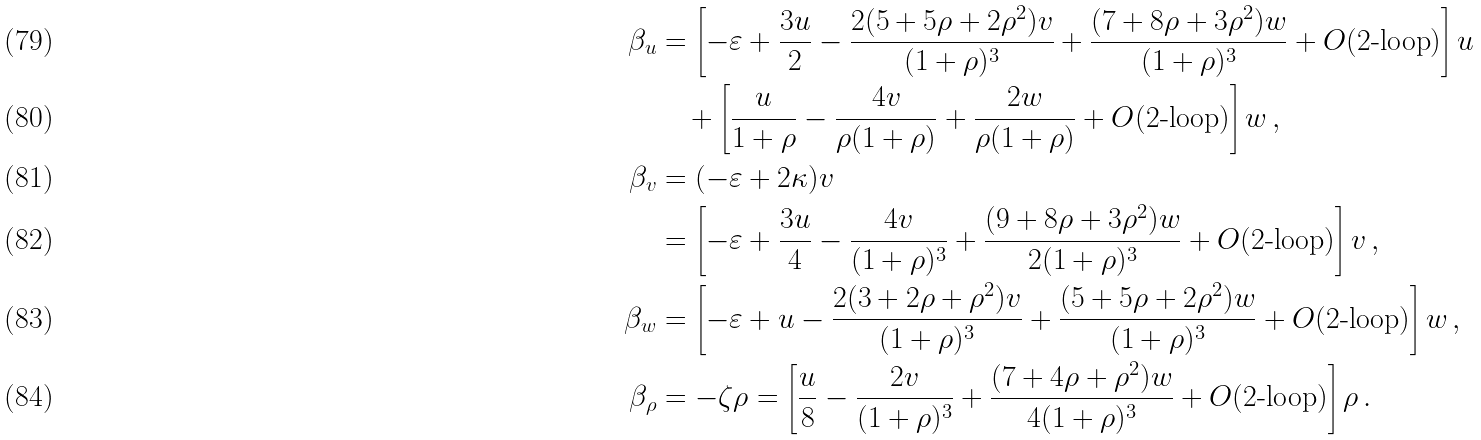<formula> <loc_0><loc_0><loc_500><loc_500>\beta _ { u } & = \left [ - \varepsilon + \frac { 3 u } { 2 } - \frac { 2 ( 5 + 5 \rho + 2 \rho ^ { 2 } ) v } { ( 1 + \rho ) ^ { 3 } } + \frac { ( 7 + 8 \rho + 3 \rho ^ { 2 } ) w } { ( 1 + \rho ) ^ { 3 } } + O ( \text {2-loop} ) \right ] u \\ & \quad + \left [ \frac { u } { 1 + \rho } - \frac { 4 v } { \rho ( 1 + \rho ) } + \frac { 2 w } { \rho ( 1 + \rho ) } + O ( \text {2-loop} ) \right ] w \, , \\ \beta _ { v } & = ( - \varepsilon + 2 \kappa ) v \\ & = \left [ - \varepsilon + \frac { 3 u } { 4 } - \frac { 4 v } { ( 1 + \rho ) ^ { 3 } } + \frac { ( 9 + 8 \rho + 3 \rho ^ { 2 } ) w } { 2 ( 1 + \rho ) ^ { 3 } } + O ( \text {2-loop} ) \right ] v \, , \\ \beta _ { w } & = \left [ - \varepsilon + u - \frac { 2 ( 3 + 2 \rho + \rho ^ { 2 } ) v } { ( 1 + \rho ) ^ { 3 } } + \frac { ( 5 + 5 \rho + 2 \rho ^ { 2 } ) w } { ( 1 + \rho ) ^ { 3 } } + O ( \text {2-loop} ) \right ] w \, , \\ \beta _ { \rho } & = - \zeta \rho = \left [ \frac { u } { 8 } - \frac { 2 v } { ( 1 + \rho ) ^ { 3 } } + \frac { ( 7 + 4 \rho + \rho ^ { 2 } ) w } { 4 ( 1 + \rho ) ^ { 3 } } + O ( \text {2-loop} ) \right ] \rho \, .</formula> 